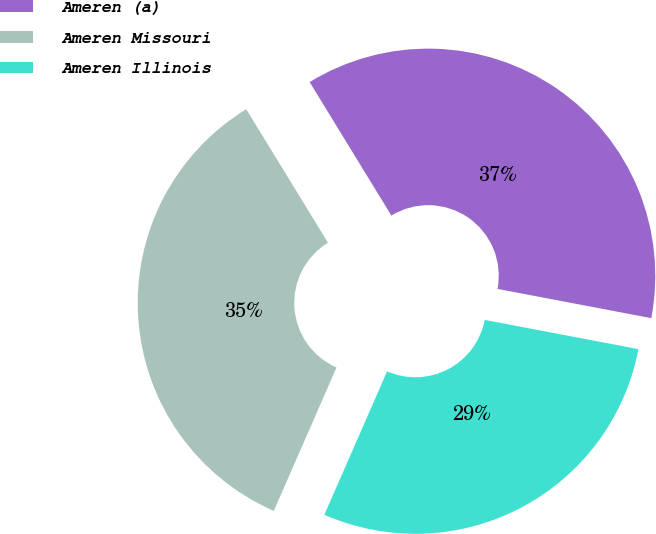Convert chart to OTSL. <chart><loc_0><loc_0><loc_500><loc_500><pie_chart><fcel>Ameren (a)<fcel>Ameren Missouri<fcel>Ameren Illinois<nl><fcel>36.73%<fcel>34.69%<fcel>28.57%<nl></chart> 